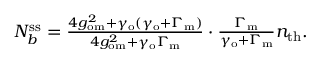<formula> <loc_0><loc_0><loc_500><loc_500>\begin{array} { r } { N _ { b } ^ { s s } = \frac { 4 g _ { o m } ^ { 2 } + \gamma _ { o } ( \gamma _ { o } + \Gamma _ { m } ) } { 4 g _ { o m } ^ { 2 } + \gamma _ { o } \Gamma _ { m } } \cdot \frac { \Gamma _ { m } } { \gamma _ { o } + \Gamma _ { m } } n _ { t h } . } \end{array}</formula> 